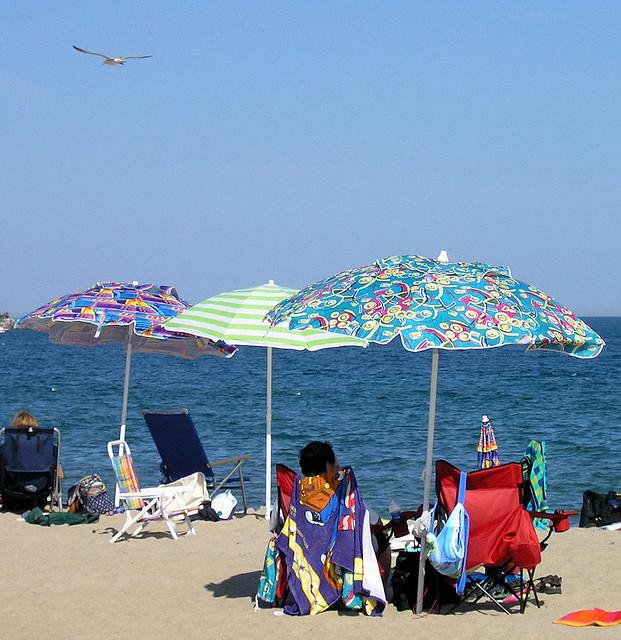What other situation might the standing items be useful for?

Choices:
A) hurricane
B) snow
C) rain
D) wind rain 